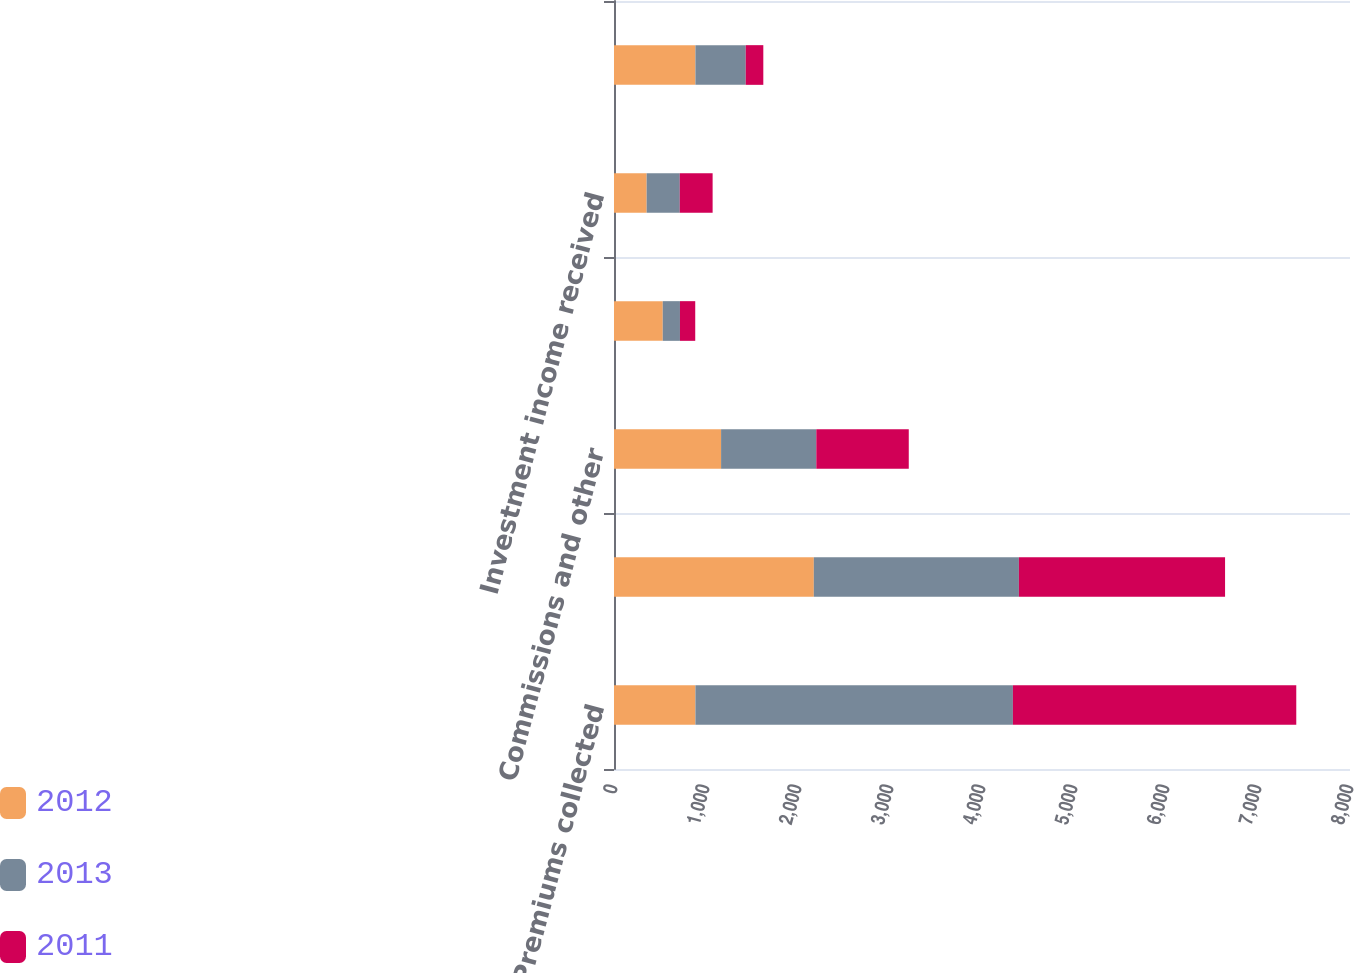<chart> <loc_0><loc_0><loc_500><loc_500><stacked_bar_chart><ecel><fcel>Premiums collected<fcel>Loss and loss expenses paid<fcel>Commissions and other<fcel>Cash flow from underwriting<fcel>Investment income received<fcel>Cash flow from operating<nl><fcel>2012<fcel>885<fcel>2172<fcel>1164<fcel>530<fcel>355<fcel>885<nl><fcel>2013<fcel>3451<fcel>2229<fcel>1035<fcel>187<fcel>360<fcel>547<nl><fcel>2011<fcel>3080<fcel>2241<fcel>1005<fcel>166<fcel>357<fcel>191<nl></chart> 